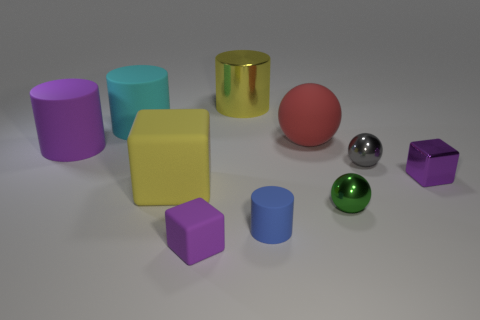Are there fewer small shiny spheres in front of the blue rubber object than small gray balls?
Offer a terse response. Yes. What is the shape of the tiny green thing?
Offer a very short reply. Sphere. There is a thing on the right side of the gray ball; how big is it?
Offer a very short reply. Small. What is the color of the metal thing that is the same size as the matte sphere?
Provide a succinct answer. Yellow. Are there any other small cubes that have the same color as the small matte cube?
Give a very brief answer. Yes. Is the number of green things right of the green object less than the number of green balls that are behind the tiny purple rubber thing?
Provide a short and direct response. Yes. What is the object that is right of the blue cylinder and behind the large purple rubber thing made of?
Offer a very short reply. Rubber. There is a green shiny thing; is its shape the same as the tiny object behind the purple shiny block?
Your answer should be compact. Yes. How many other objects are there of the same size as the yellow cylinder?
Your answer should be very brief. 4. Is the number of metallic spheres greater than the number of tiny cyan shiny cubes?
Offer a very short reply. Yes. 